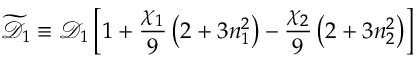<formula> <loc_0><loc_0><loc_500><loc_500>\widetilde { \mathcal { D } } _ { 1 } \equiv \mathcal { D } _ { 1 } \left [ 1 + \frac { \chi _ { 1 } } { 9 } \left ( 2 + 3 n _ { 1 } ^ { 2 } \right ) - \frac { \chi _ { 2 } } { 9 } \left ( 2 + 3 n _ { 2 } ^ { 2 } \right ) \right ]</formula> 